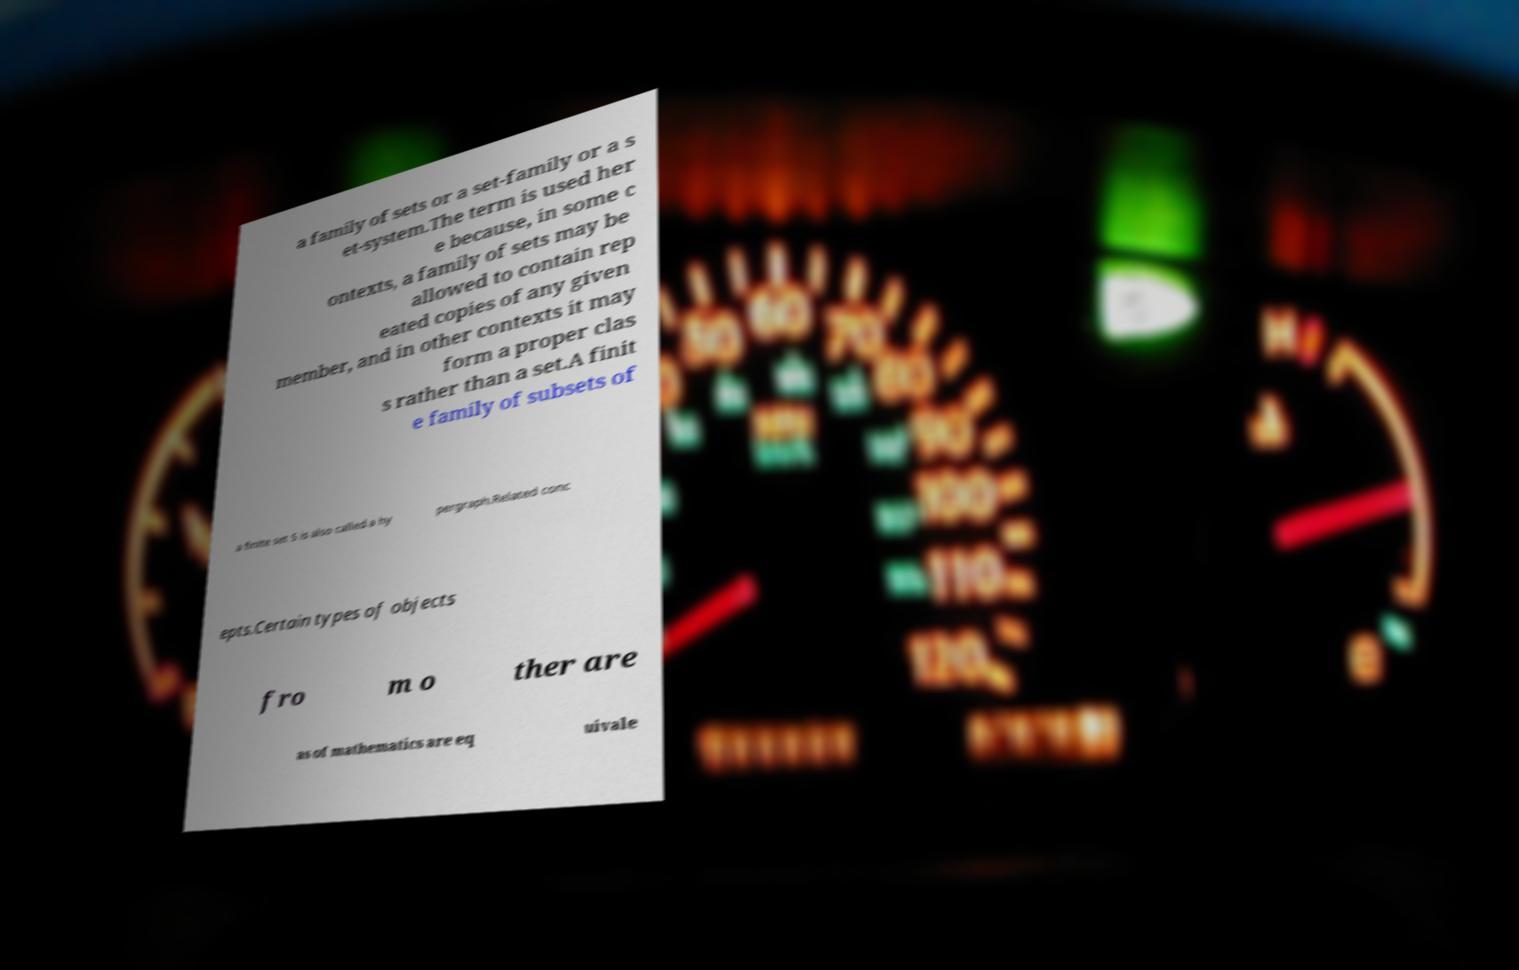What messages or text are displayed in this image? I need them in a readable, typed format. a family of sets or a set-family or a s et-system.The term is used her e because, in some c ontexts, a family of sets may be allowed to contain rep eated copies of any given member, and in other contexts it may form a proper clas s rather than a set.A finit e family of subsets of a finite set S is also called a hy pergraph.Related conc epts.Certain types of objects fro m o ther are as of mathematics are eq uivale 